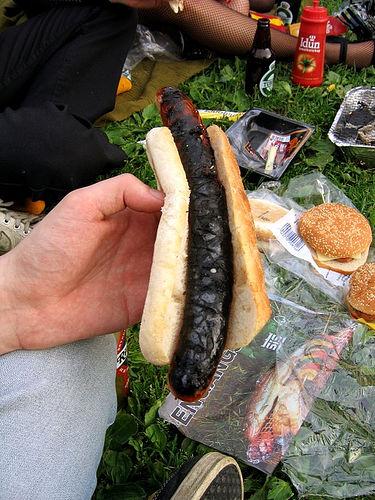What color are the pants?
Keep it brief. Blue. Is the hotdog burn?
Write a very short answer. Yes. What is the person holding in their hand?
Quick response, please. Hot dog. 